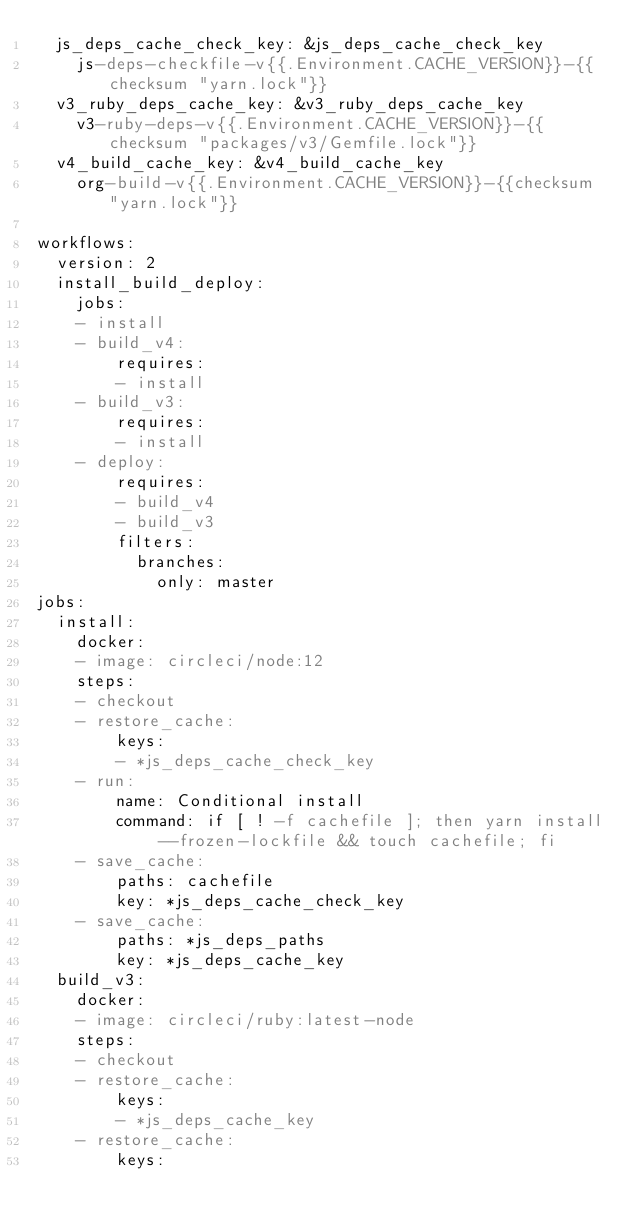<code> <loc_0><loc_0><loc_500><loc_500><_YAML_>  js_deps_cache_check_key: &js_deps_cache_check_key
    js-deps-checkfile-v{{.Environment.CACHE_VERSION}}-{{checksum "yarn.lock"}}
  v3_ruby_deps_cache_key: &v3_ruby_deps_cache_key
    v3-ruby-deps-v{{.Environment.CACHE_VERSION}}-{{checksum "packages/v3/Gemfile.lock"}}
  v4_build_cache_key: &v4_build_cache_key
    org-build-v{{.Environment.CACHE_VERSION}}-{{checksum "yarn.lock"}}

workflows:
  version: 2
  install_build_deploy:
    jobs:
    - install
    - build_v4:
        requires:
        - install
    - build_v3:
        requires:
        - install
    - deploy:
        requires:
        - build_v4
        - build_v3
        filters:
          branches:
            only: master
jobs:
  install:
    docker:
    - image: circleci/node:12
    steps:
    - checkout
    - restore_cache:
        keys:
        - *js_deps_cache_check_key
    - run:
        name: Conditional install
        command: if [ ! -f cachefile ]; then yarn install --frozen-lockfile && touch cachefile; fi
    - save_cache:
        paths: cachefile
        key: *js_deps_cache_check_key
    - save_cache:
        paths: *js_deps_paths
        key: *js_deps_cache_key
  build_v3:
    docker:
    - image: circleci/ruby:latest-node
    steps:
    - checkout
    - restore_cache:
        keys:
        - *js_deps_cache_key
    - restore_cache:
        keys:</code> 